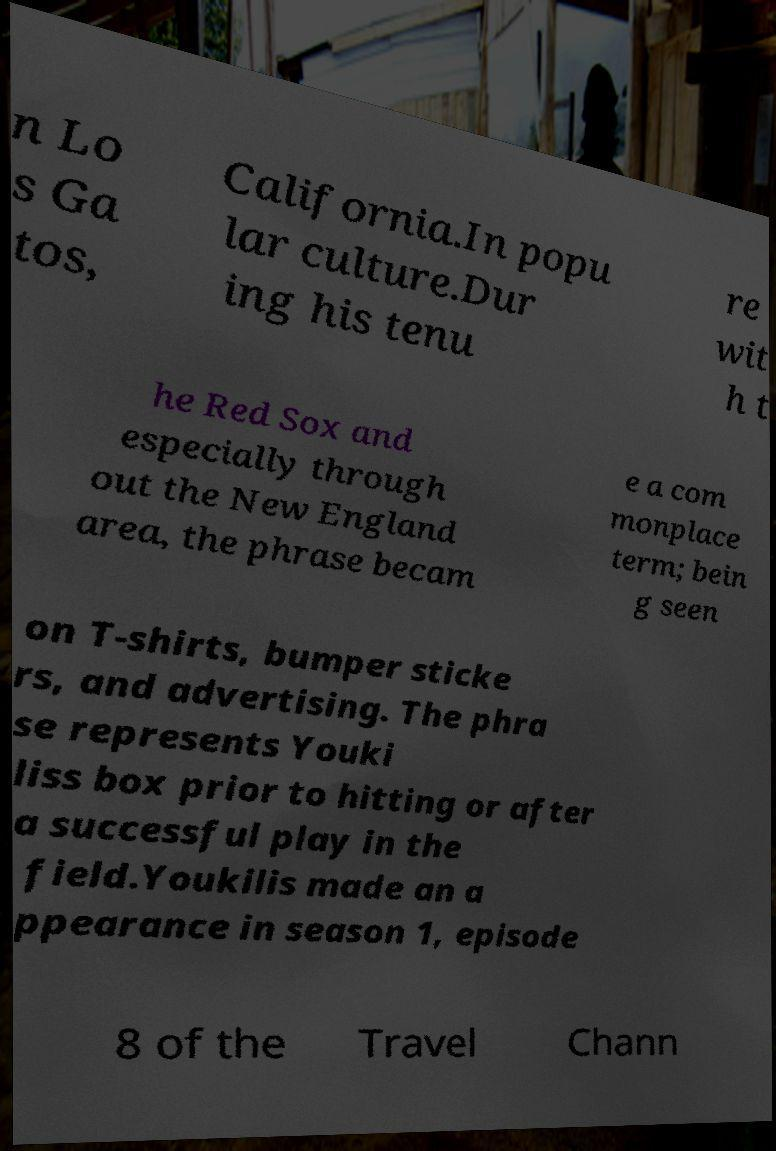What messages or text are displayed in this image? I need them in a readable, typed format. n Lo s Ga tos, California.In popu lar culture.Dur ing his tenu re wit h t he Red Sox and especially through out the New England area, the phrase becam e a com monplace term; bein g seen on T-shirts, bumper sticke rs, and advertising. The phra se represents Youki liss box prior to hitting or after a successful play in the field.Youkilis made an a ppearance in season 1, episode 8 of the Travel Chann 